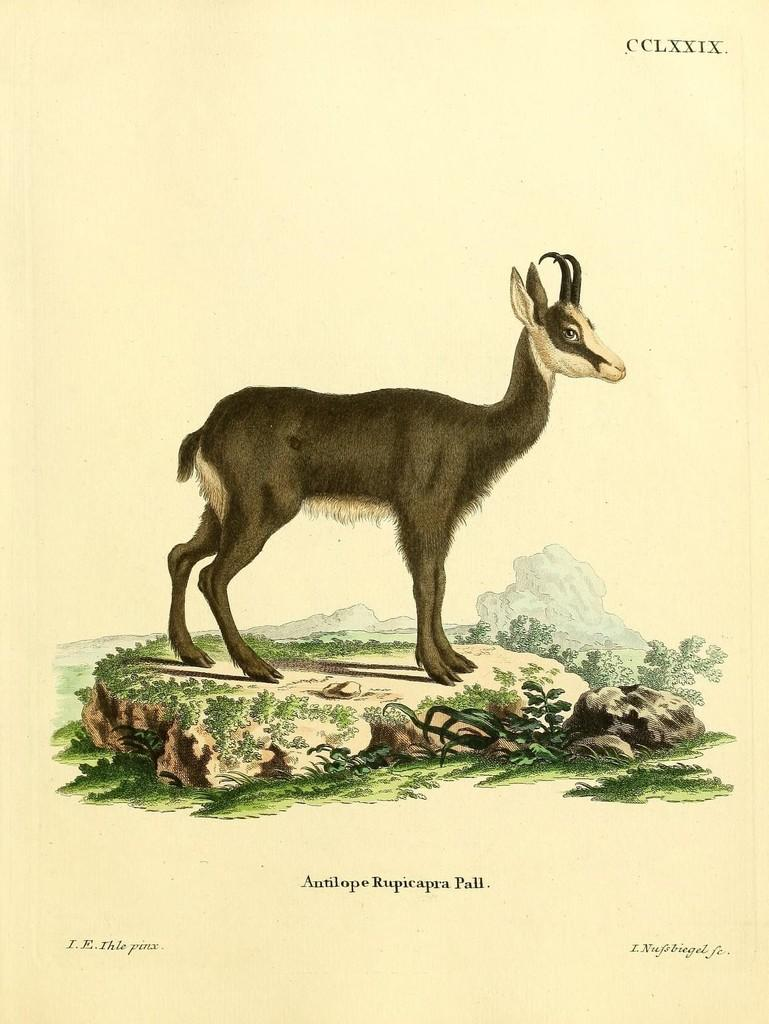What is depicted on the ground in the image? There is a drawing of an animal on the ground. What else can be seen alongside the drawing? There is text associated with the drawing. What type of twig is being used as a prop in the image? There is no twig present in the image. 